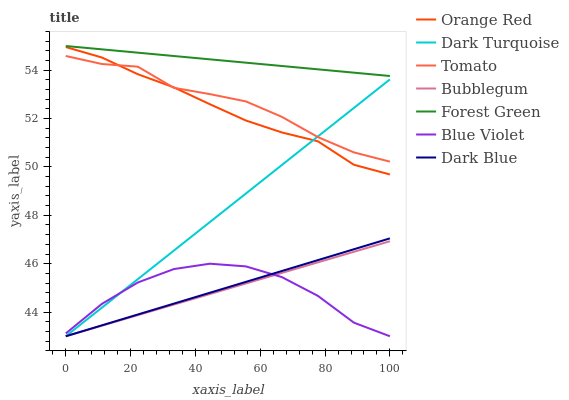Does Blue Violet have the minimum area under the curve?
Answer yes or no. Yes. Does Forest Green have the maximum area under the curve?
Answer yes or no. Yes. Does Dark Turquoise have the minimum area under the curve?
Answer yes or no. No. Does Dark Turquoise have the maximum area under the curve?
Answer yes or no. No. Is Forest Green the smoothest?
Answer yes or no. Yes. Is Blue Violet the roughest?
Answer yes or no. Yes. Is Dark Turquoise the smoothest?
Answer yes or no. No. Is Dark Turquoise the roughest?
Answer yes or no. No. Does Dark Turquoise have the lowest value?
Answer yes or no. Yes. Does Forest Green have the lowest value?
Answer yes or no. No. Does Forest Green have the highest value?
Answer yes or no. Yes. Does Dark Turquoise have the highest value?
Answer yes or no. No. Is Bubblegum less than Forest Green?
Answer yes or no. Yes. Is Tomato greater than Dark Blue?
Answer yes or no. Yes. Does Bubblegum intersect Dark Blue?
Answer yes or no. Yes. Is Bubblegum less than Dark Blue?
Answer yes or no. No. Is Bubblegum greater than Dark Blue?
Answer yes or no. No. Does Bubblegum intersect Forest Green?
Answer yes or no. No. 